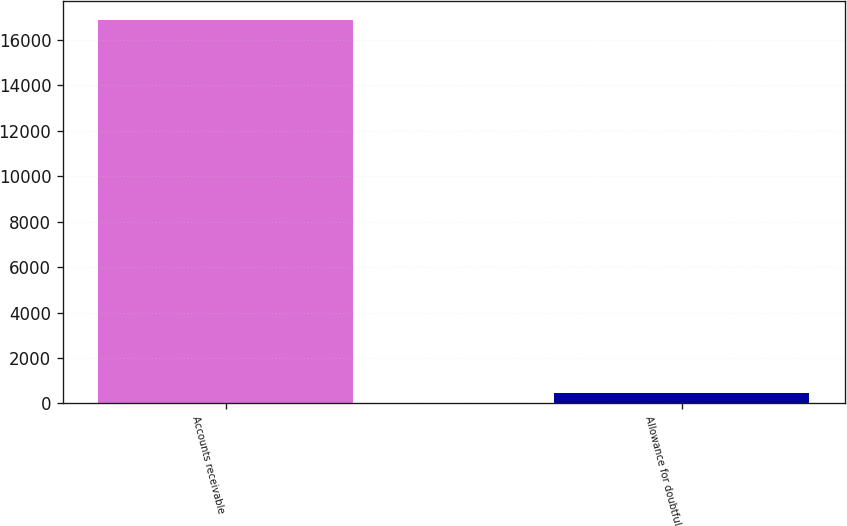<chart> <loc_0><loc_0><loc_500><loc_500><bar_chart><fcel>Accounts receivable<fcel>Allowance for doubtful<nl><fcel>16871<fcel>464<nl></chart> 